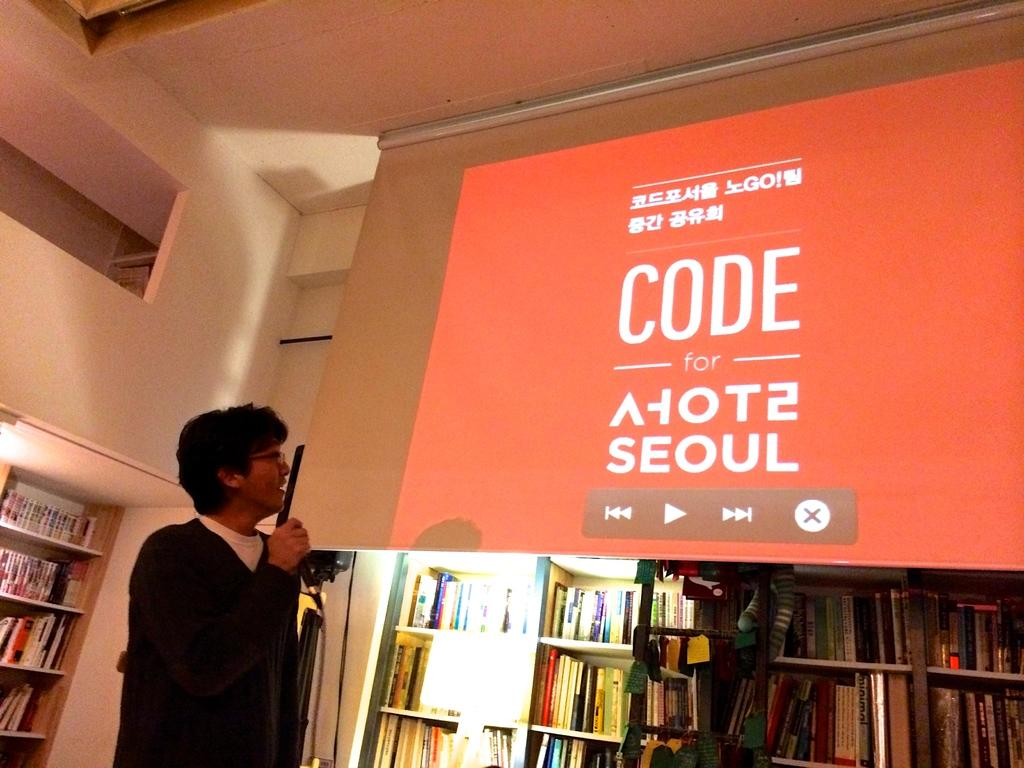<image>
Offer a succinct explanation of the picture presented. A large screen has the word code on it in white lettering. 